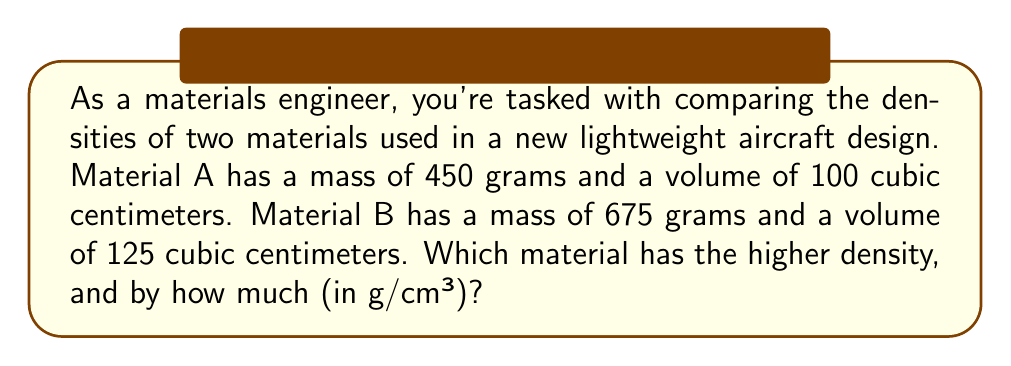Can you answer this question? Let's approach this step-by-step:

1) First, recall the formula for density:
   $$\text{Density} = \frac{\text{Mass}}{\text{Volume}}$$

2) For Material A:
   $$\text{Density}_A = \frac{450 \text{ g}}{100 \text{ cm}^3} = 4.5 \text{ g/cm}^3$$

3) For Material B:
   $$\text{Density}_B = \frac{675 \text{ g}}{125 \text{ cm}^3} = 5.4 \text{ g/cm}^3$$

4) To determine which material has the higher density, we compare:
   $5.4 \text{ g/cm}^3 > 4.5 \text{ g/cm}^3$
   Therefore, Material B has the higher density.

5) To find the difference in density:
   $$5.4 \text{ g/cm}^3 - 4.5 \text{ g/cm}^3 = 0.9 \text{ g/cm}^3$$

Thus, Material B has a higher density by 0.9 g/cm³.
Answer: Material B; 0.9 g/cm³ 